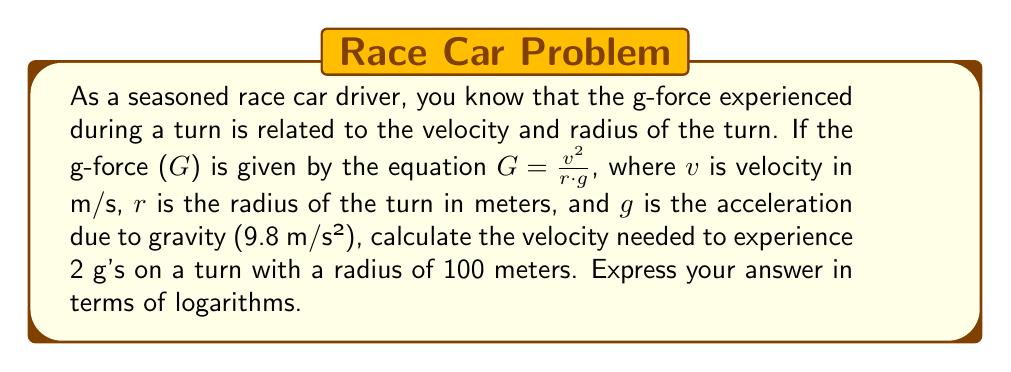Can you solve this math problem? Let's approach this step-by-step:

1) We start with the equation for g-force:
   $G = \frac{v^2}{r\cdot g}$

2) We're given that G = 2, r = 100 m, and g = 9.8 m/s². Let's substitute these values:
   $2 = \frac{v^2}{100 \cdot 9.8}$

3) Multiply both sides by 100 * 9.8:
   $2 \cdot 100 \cdot 9.8 = v^2$

4) Simplify:
   $1960 = v^2$

5) To solve for v, we need to take the square root of both sides:
   $\sqrt{1960} = v$

6) To express this in terms of logarithms, we can use the property:
   $\log_a(\sqrt{x}) = \frac{1}{2}\log_a(x)$

7) Applying this to our equation:
   $v = \sqrt{1960} = e^{\frac{1}{2}\ln(1960)}$

8) Therefore, we can express v as:
   $v = e^{\frac{1}{2}\ln(1960)}$
Answer: $v = e^{\frac{1}{2}\ln(1960)}$ m/s 